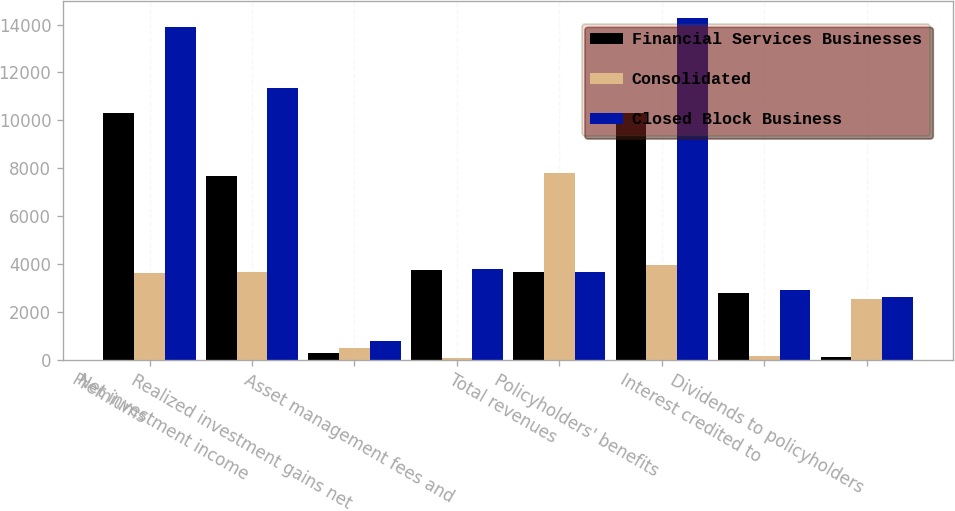Convert chart to OTSL. <chart><loc_0><loc_0><loc_500><loc_500><stacked_bar_chart><ecel><fcel>Premiums<fcel>Net investment income<fcel>Realized investment gains net<fcel>Asset management fees and<fcel>Total revenues<fcel>Policyholders' benefits<fcel>Interest credited to<fcel>Dividends to policyholders<nl><fcel>Financial Services Businesses<fcel>10309<fcel>7674<fcel>293<fcel>3747<fcel>3639.5<fcel>10316<fcel>2778<fcel>104<nl><fcel>Consolidated<fcel>3599<fcel>3680<fcel>481<fcel>52<fcel>7812<fcel>3967<fcel>139<fcel>2518<nl><fcel>Closed Block Business<fcel>13908<fcel>11354<fcel>774<fcel>3799<fcel>3639.5<fcel>14283<fcel>2917<fcel>2622<nl></chart> 